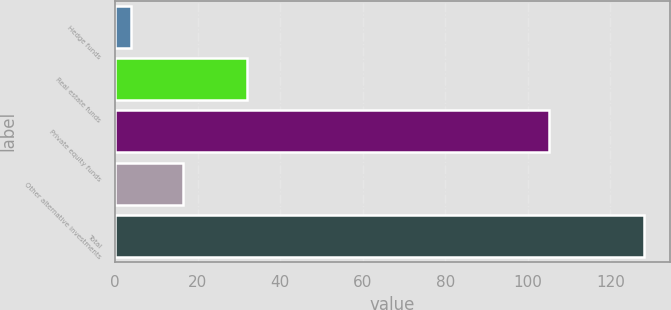<chart> <loc_0><loc_0><loc_500><loc_500><bar_chart><fcel>Hedge funds<fcel>Real estate funds<fcel>Private equity funds<fcel>Other alternative investments<fcel>Total<nl><fcel>4<fcel>32<fcel>105<fcel>16.4<fcel>128<nl></chart> 